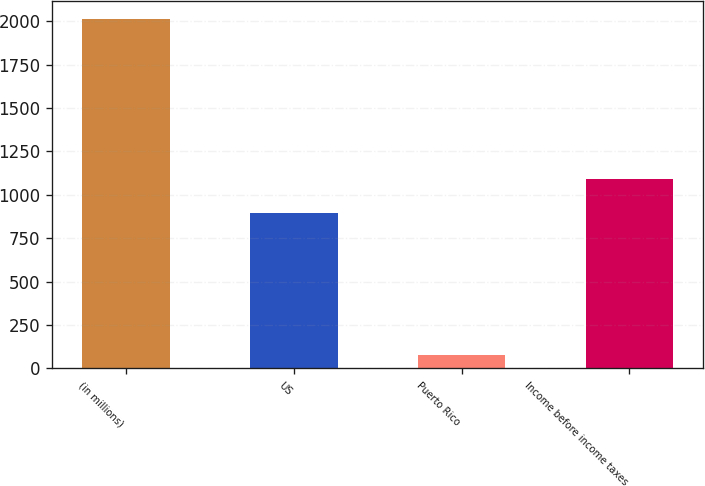Convert chart to OTSL. <chart><loc_0><loc_0><loc_500><loc_500><bar_chart><fcel>(in millions)<fcel>US<fcel>Puerto Rico<fcel>Income before income taxes<nl><fcel>2015<fcel>898<fcel>80<fcel>1091.5<nl></chart> 